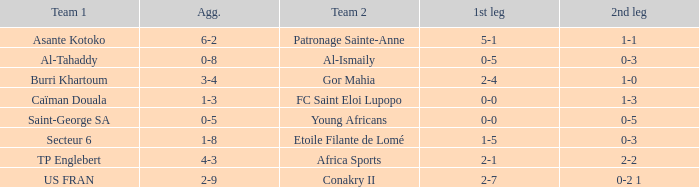Which teams had an aggregate score of 3-4? Burri Khartoum. 